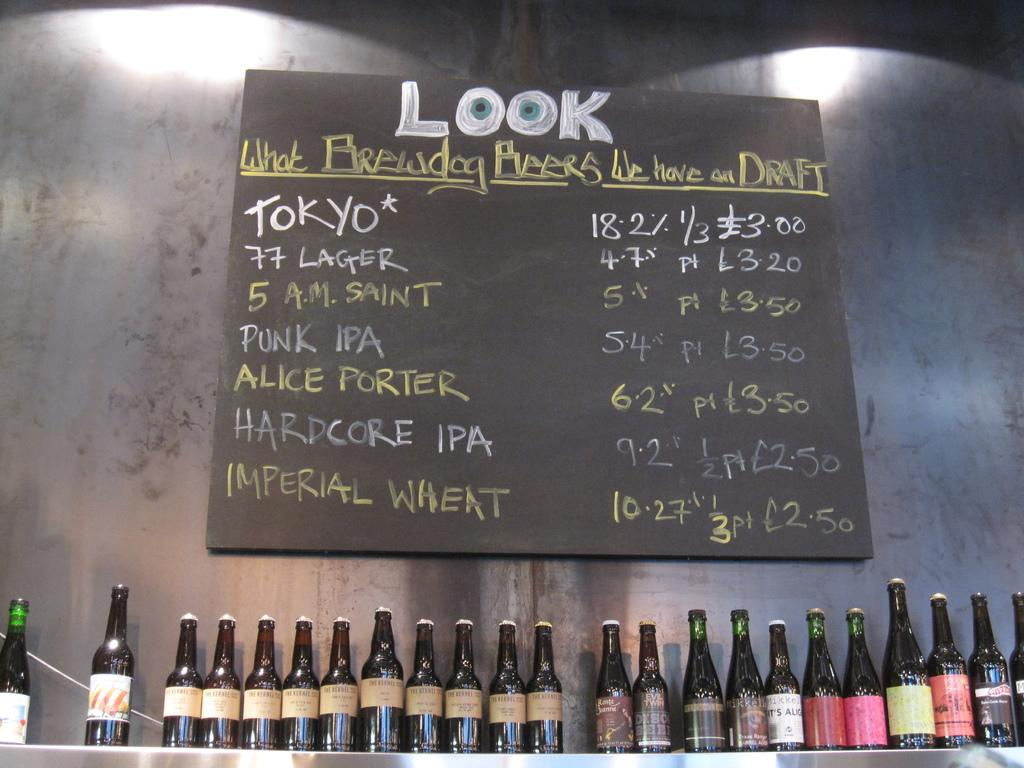<image>
Offer a succinct explanation of the picture presented. A chalkboard sign shows what beer are currently on draft. 